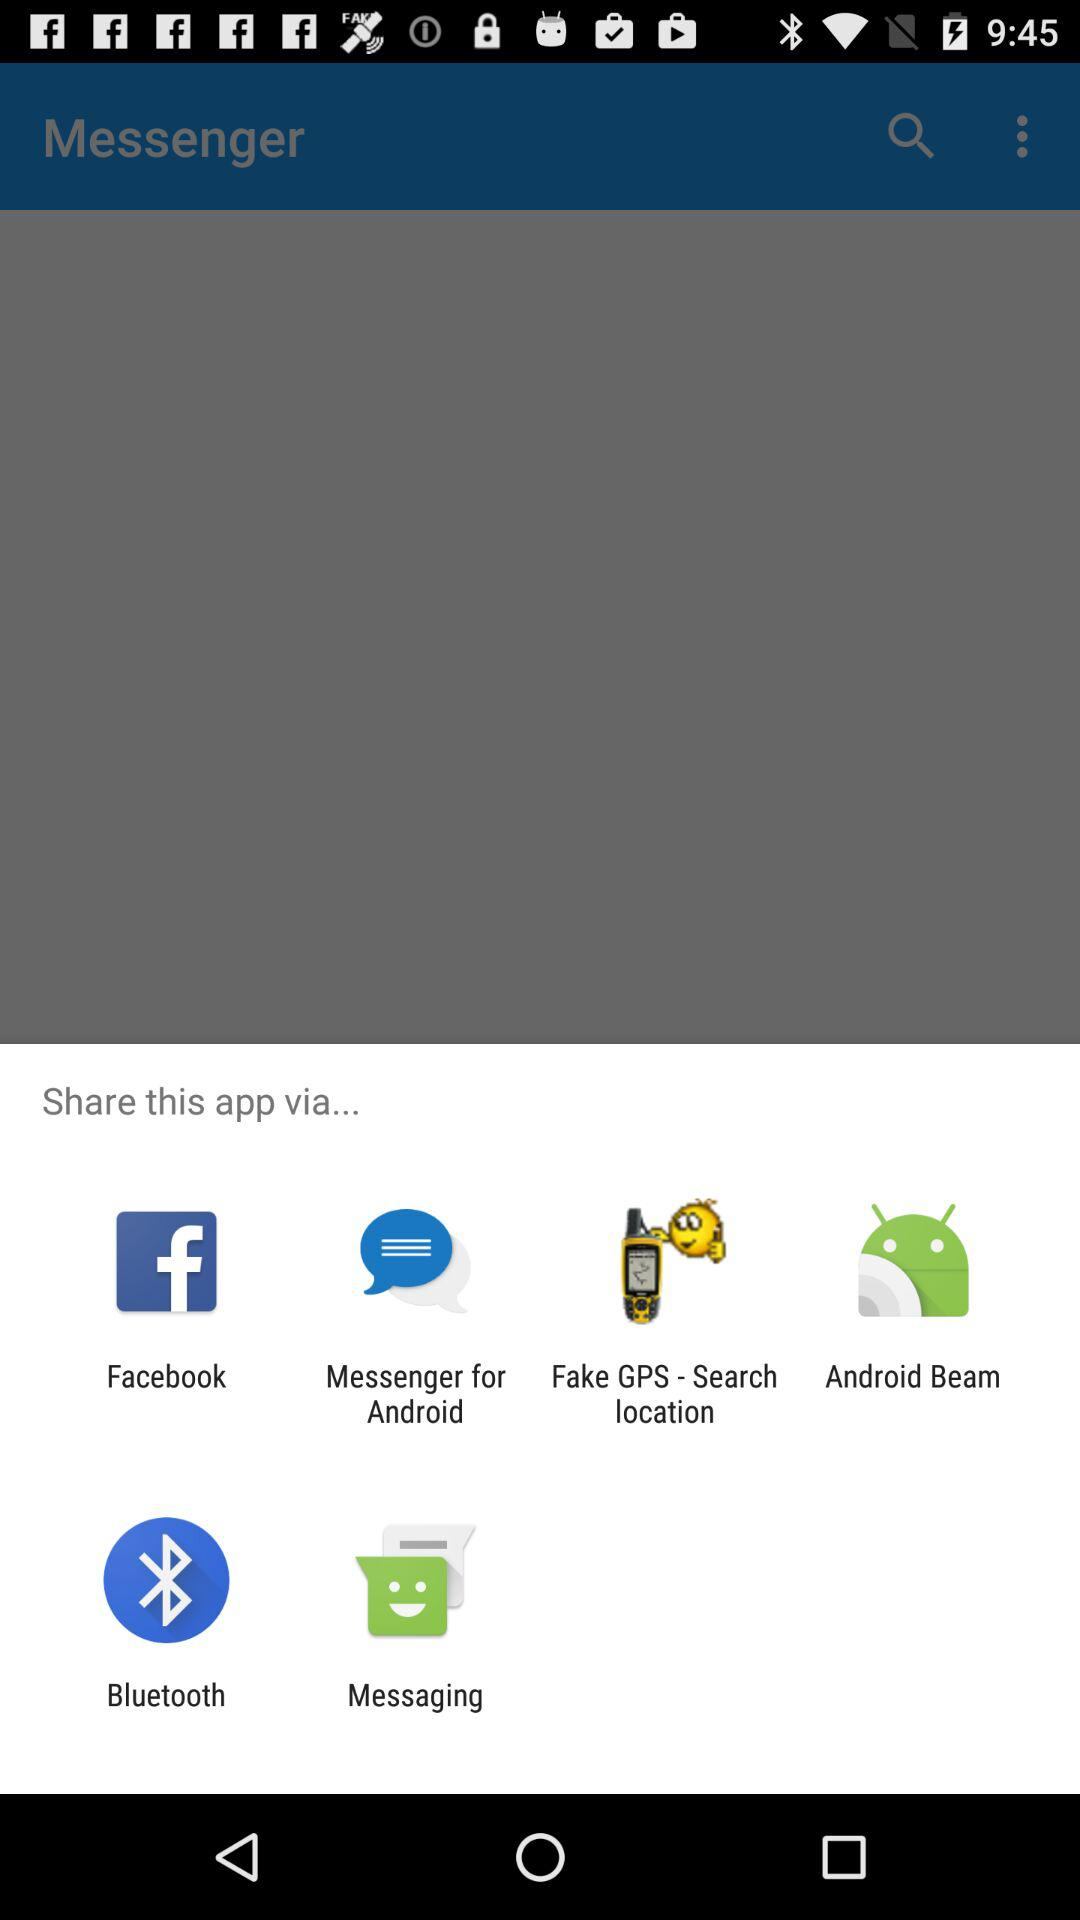What is the name of the application? The name of the application is "Messenger". 